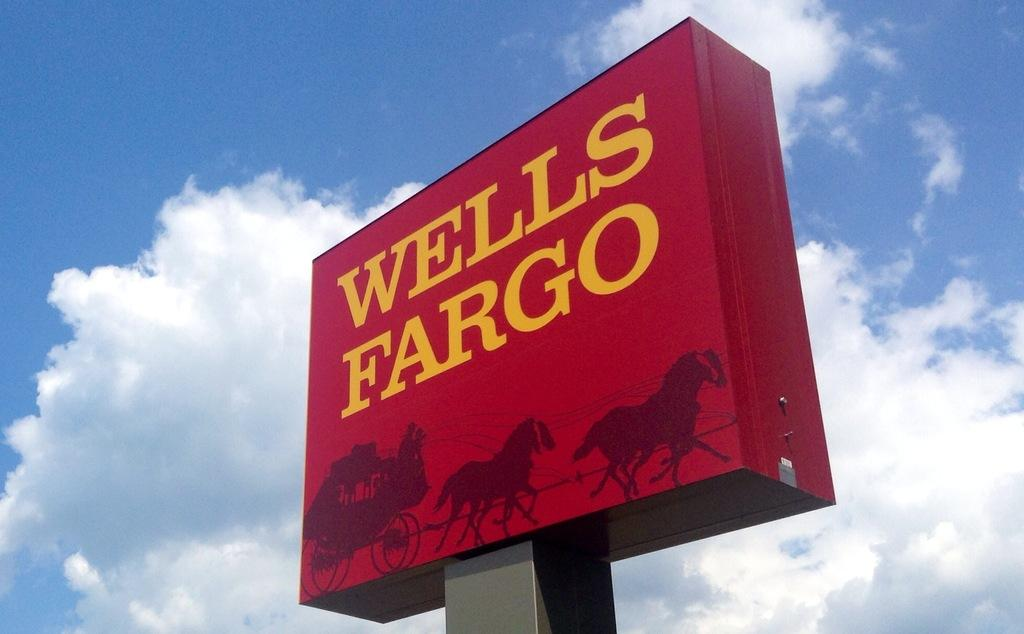<image>
Relay a brief, clear account of the picture shown. Big red Wells Fargo sign on a gray pole. 